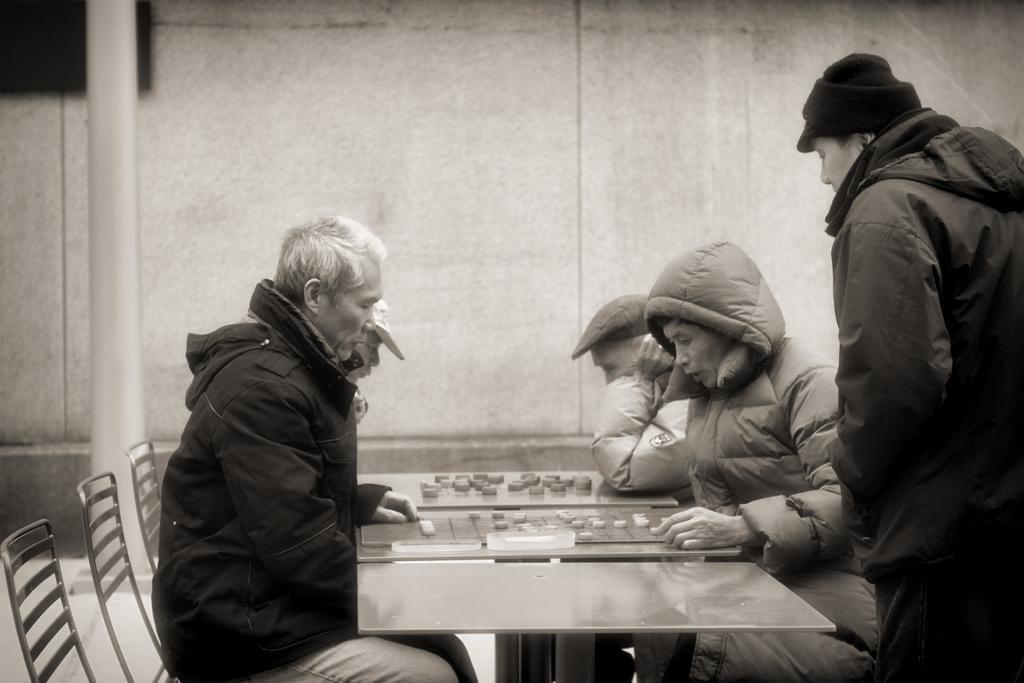In one or two sentences, can you explain what this image depicts? In the picture there are many people sitting on the chair and table in front of them on the table there are playing a game one person is standing near them. 